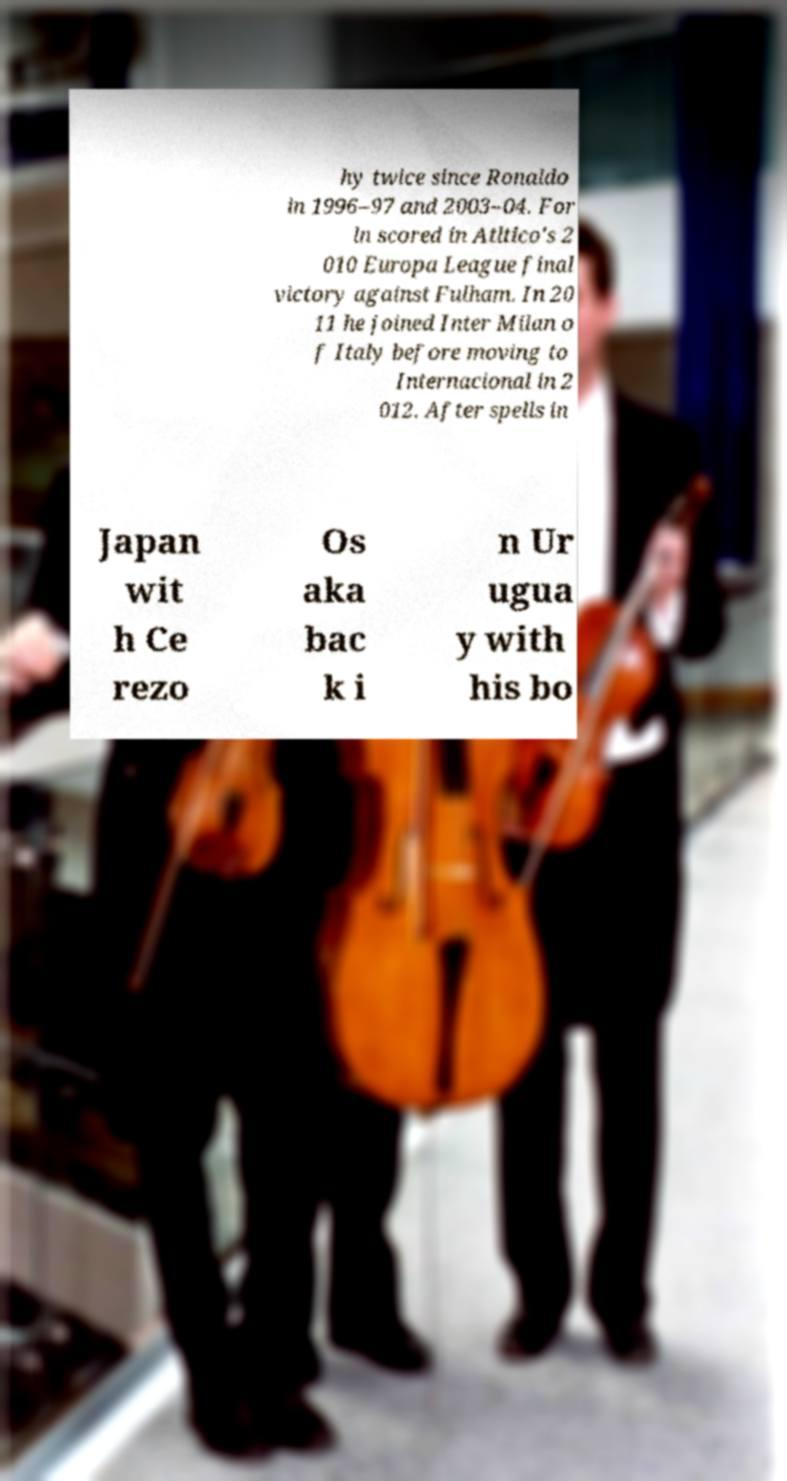Could you extract and type out the text from this image? hy twice since Ronaldo in 1996–97 and 2003–04. For ln scored in Atltico's 2 010 Europa League final victory against Fulham. In 20 11 he joined Inter Milan o f Italy before moving to Internacional in 2 012. After spells in Japan wit h Ce rezo Os aka bac k i n Ur ugua y with his bo 